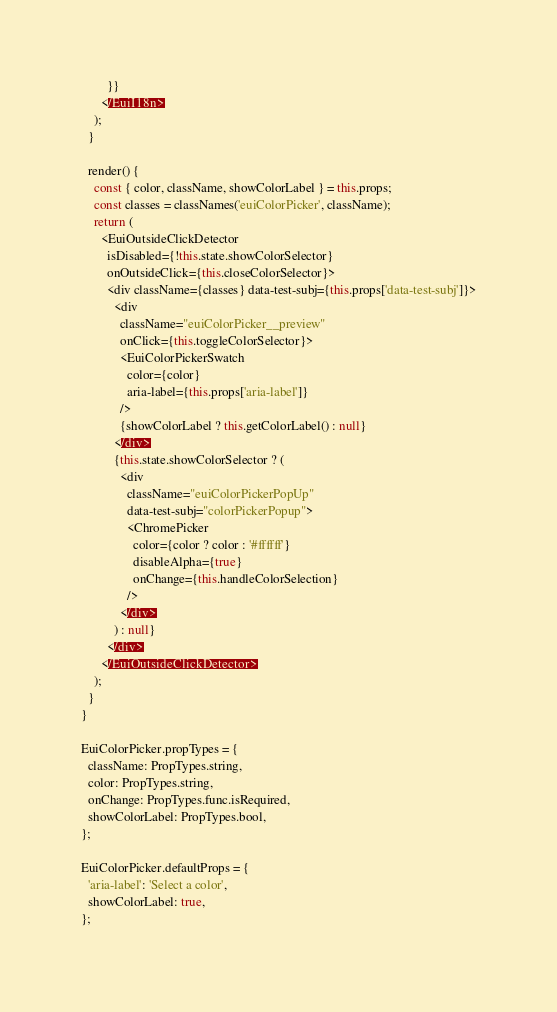<code> <loc_0><loc_0><loc_500><loc_500><_JavaScript_>        }}
      </EuiI18n>
    );
  }

  render() {
    const { color, className, showColorLabel } = this.props;
    const classes = classNames('euiColorPicker', className);
    return (
      <EuiOutsideClickDetector
        isDisabled={!this.state.showColorSelector}
        onOutsideClick={this.closeColorSelector}>
        <div className={classes} data-test-subj={this.props['data-test-subj']}>
          <div
            className="euiColorPicker__preview"
            onClick={this.toggleColorSelector}>
            <EuiColorPickerSwatch
              color={color}
              aria-label={this.props['aria-label']}
            />
            {showColorLabel ? this.getColorLabel() : null}
          </div>
          {this.state.showColorSelector ? (
            <div
              className="euiColorPickerPopUp"
              data-test-subj="colorPickerPopup">
              <ChromePicker
                color={color ? color : '#ffffff'}
                disableAlpha={true}
                onChange={this.handleColorSelection}
              />
            </div>
          ) : null}
        </div>
      </EuiOutsideClickDetector>
    );
  }
}

EuiColorPicker.propTypes = {
  className: PropTypes.string,
  color: PropTypes.string,
  onChange: PropTypes.func.isRequired,
  showColorLabel: PropTypes.bool,
};

EuiColorPicker.defaultProps = {
  'aria-label': 'Select a color',
  showColorLabel: true,
};
</code> 